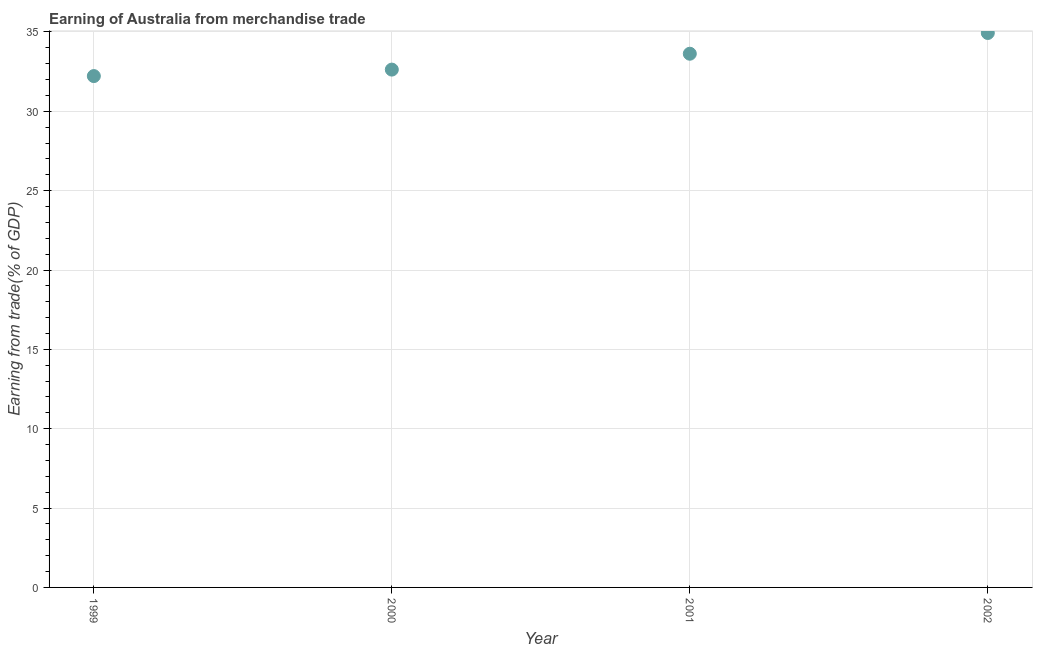What is the earning from merchandise trade in 2002?
Your answer should be very brief. 34.94. Across all years, what is the maximum earning from merchandise trade?
Your response must be concise. 34.94. Across all years, what is the minimum earning from merchandise trade?
Offer a very short reply. 32.22. In which year was the earning from merchandise trade maximum?
Keep it short and to the point. 2002. In which year was the earning from merchandise trade minimum?
Your response must be concise. 1999. What is the sum of the earning from merchandise trade?
Provide a succinct answer. 133.42. What is the difference between the earning from merchandise trade in 1999 and 2002?
Provide a short and direct response. -2.72. What is the average earning from merchandise trade per year?
Your answer should be very brief. 33.35. What is the median earning from merchandise trade?
Make the answer very short. 33.13. In how many years, is the earning from merchandise trade greater than 5 %?
Ensure brevity in your answer.  4. What is the ratio of the earning from merchandise trade in 1999 to that in 2001?
Provide a succinct answer. 0.96. Is the earning from merchandise trade in 2000 less than that in 2001?
Your response must be concise. Yes. Is the difference between the earning from merchandise trade in 1999 and 2002 greater than the difference between any two years?
Provide a short and direct response. Yes. What is the difference between the highest and the second highest earning from merchandise trade?
Offer a very short reply. 1.31. Is the sum of the earning from merchandise trade in 1999 and 2001 greater than the maximum earning from merchandise trade across all years?
Your answer should be compact. Yes. What is the difference between the highest and the lowest earning from merchandise trade?
Your answer should be very brief. 2.72. Does the earning from merchandise trade monotonically increase over the years?
Keep it short and to the point. Yes. How many dotlines are there?
Your response must be concise. 1. Does the graph contain any zero values?
Your response must be concise. No. What is the title of the graph?
Make the answer very short. Earning of Australia from merchandise trade. What is the label or title of the X-axis?
Offer a very short reply. Year. What is the label or title of the Y-axis?
Your answer should be compact. Earning from trade(% of GDP). What is the Earning from trade(% of GDP) in 1999?
Provide a short and direct response. 32.22. What is the Earning from trade(% of GDP) in 2000?
Your answer should be compact. 32.63. What is the Earning from trade(% of GDP) in 2001?
Provide a short and direct response. 33.63. What is the Earning from trade(% of GDP) in 2002?
Your answer should be very brief. 34.94. What is the difference between the Earning from trade(% of GDP) in 1999 and 2000?
Your answer should be very brief. -0.41. What is the difference between the Earning from trade(% of GDP) in 1999 and 2001?
Provide a short and direct response. -1.41. What is the difference between the Earning from trade(% of GDP) in 1999 and 2002?
Ensure brevity in your answer.  -2.72. What is the difference between the Earning from trade(% of GDP) in 2000 and 2001?
Offer a very short reply. -1. What is the difference between the Earning from trade(% of GDP) in 2000 and 2002?
Give a very brief answer. -2.31. What is the difference between the Earning from trade(% of GDP) in 2001 and 2002?
Give a very brief answer. -1.31. What is the ratio of the Earning from trade(% of GDP) in 1999 to that in 2000?
Keep it short and to the point. 0.99. What is the ratio of the Earning from trade(% of GDP) in 1999 to that in 2001?
Offer a terse response. 0.96. What is the ratio of the Earning from trade(% of GDP) in 1999 to that in 2002?
Your response must be concise. 0.92. What is the ratio of the Earning from trade(% of GDP) in 2000 to that in 2001?
Your response must be concise. 0.97. What is the ratio of the Earning from trade(% of GDP) in 2000 to that in 2002?
Your answer should be compact. 0.93. What is the ratio of the Earning from trade(% of GDP) in 2001 to that in 2002?
Provide a short and direct response. 0.96. 